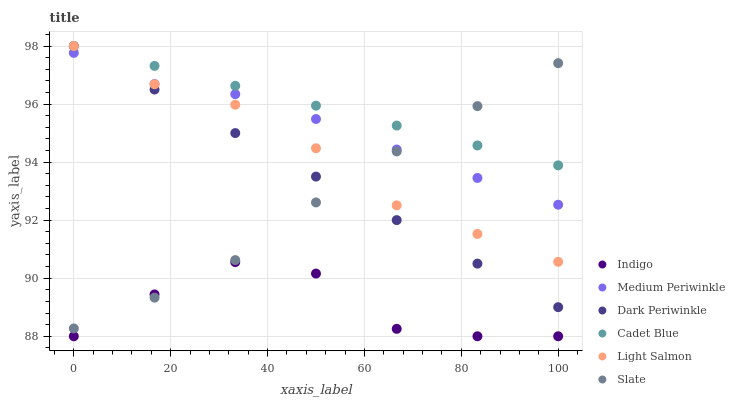Does Indigo have the minimum area under the curve?
Answer yes or no. Yes. Does Cadet Blue have the maximum area under the curve?
Answer yes or no. Yes. Does Cadet Blue have the minimum area under the curve?
Answer yes or no. No. Does Indigo have the maximum area under the curve?
Answer yes or no. No. Is Dark Periwinkle the smoothest?
Answer yes or no. Yes. Is Indigo the roughest?
Answer yes or no. Yes. Is Cadet Blue the smoothest?
Answer yes or no. No. Is Cadet Blue the roughest?
Answer yes or no. No. Does Indigo have the lowest value?
Answer yes or no. Yes. Does Cadet Blue have the lowest value?
Answer yes or no. No. Does Dark Periwinkle have the highest value?
Answer yes or no. Yes. Does Indigo have the highest value?
Answer yes or no. No. Is Indigo less than Light Salmon?
Answer yes or no. Yes. Is Medium Periwinkle greater than Indigo?
Answer yes or no. Yes. Does Medium Periwinkle intersect Light Salmon?
Answer yes or no. Yes. Is Medium Periwinkle less than Light Salmon?
Answer yes or no. No. Is Medium Periwinkle greater than Light Salmon?
Answer yes or no. No. Does Indigo intersect Light Salmon?
Answer yes or no. No. 